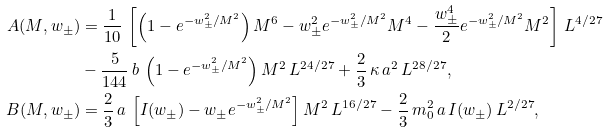<formula> <loc_0><loc_0><loc_500><loc_500>A ( M , w _ { \pm } ) & = \frac { 1 } { 1 0 } \, \left [ \left ( 1 - e ^ { - w _ { \pm } ^ { 2 } / M ^ { 2 } } \right ) M ^ { 6 } - w _ { \pm } ^ { 2 } e ^ { - w _ { \pm } ^ { 2 } / M ^ { 2 } } M ^ { 4 } - \frac { w _ { \pm } ^ { 4 } } { 2 } e ^ { - w _ { \pm } ^ { 2 } / M ^ { 2 } } M ^ { 2 } \right ] \, L ^ { 4 / 2 7 } \\ & - \frac { 5 } { 1 4 4 } \, b \, \left ( 1 - e ^ { - w _ { \pm } ^ { 2 } / M ^ { 2 } } \right ) M ^ { 2 } \, L ^ { 2 4 / 2 7 } + \frac { 2 } { 3 } \, \kappa \, a ^ { 2 } \, L ^ { 2 8 / 2 7 } , \\ B ( M , w _ { \pm } ) & = \frac { 2 } { 3 } \, a \, \left [ I ( w _ { \pm } ) - w _ { \pm } e ^ { - w _ { \pm } ^ { 2 } / M ^ { 2 } } \right ] M ^ { 2 } \, L ^ { 1 6 / 2 7 } - \frac { 2 } { 3 } \, m _ { 0 } ^ { 2 } \, a \, I ( w _ { \pm } ) \, L ^ { 2 / 2 7 } ,</formula> 